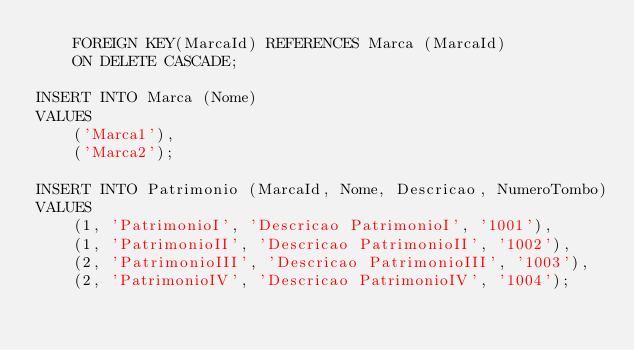<code> <loc_0><loc_0><loc_500><loc_500><_SQL_>    FOREIGN KEY(MarcaId) REFERENCES Marca (MarcaId)
    ON DELETE CASCADE;

INSERT INTO Marca (Nome) 
VALUES 
	('Marca1'),
	('Marca2');

INSERT INTO Patrimonio (MarcaId, Nome, Descricao, NumeroTombo)
VALUES
	(1, 'PatrimonioI', 'Descricao PatrimonioI', '1001'),
	(1, 'PatrimonioII', 'Descricao PatrimonioII', '1002'),
	(2, 'PatrimonioIII', 'Descricao PatrimonioIII', '1003'),
	(2, 'PatrimonioIV', 'Descricao PatrimonioIV', '1004');</code> 